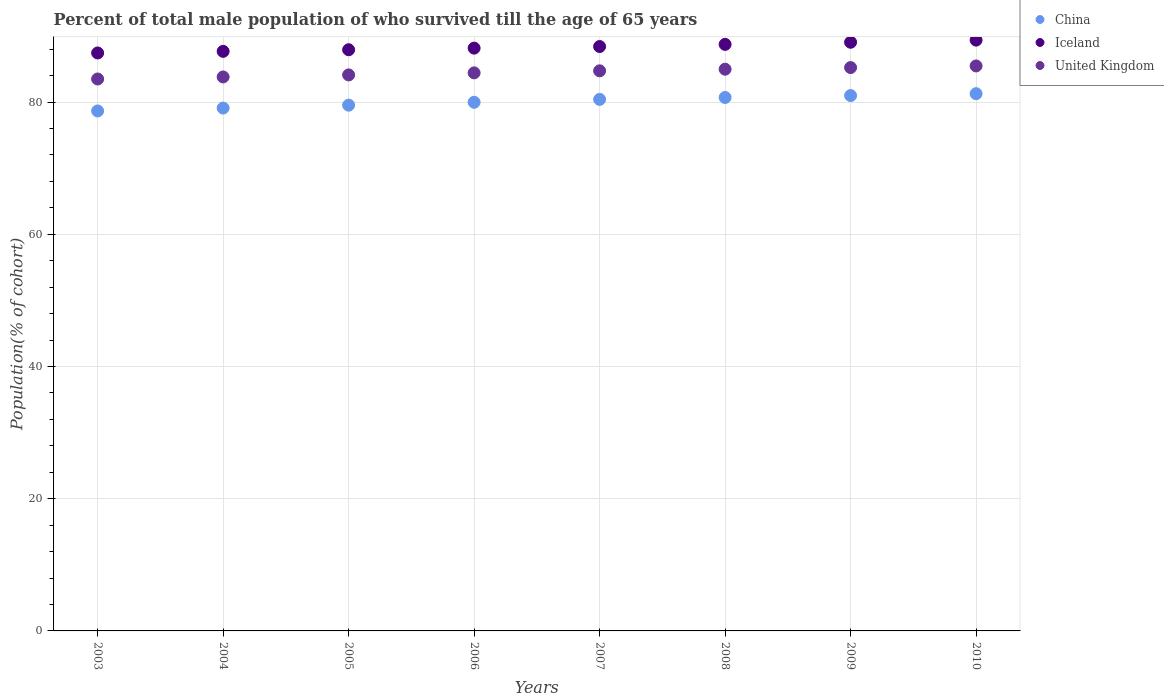What is the percentage of total male population who survived till the age of 65 years in Iceland in 2007?
Provide a short and direct response. 88.41. Across all years, what is the maximum percentage of total male population who survived till the age of 65 years in China?
Give a very brief answer. 81.27. Across all years, what is the minimum percentage of total male population who survived till the age of 65 years in Iceland?
Offer a very short reply. 87.43. In which year was the percentage of total male population who survived till the age of 65 years in China minimum?
Offer a terse response. 2003. What is the total percentage of total male population who survived till the age of 65 years in Iceland in the graph?
Make the answer very short. 706.75. What is the difference between the percentage of total male population who survived till the age of 65 years in United Kingdom in 2005 and that in 2006?
Make the answer very short. -0.31. What is the difference between the percentage of total male population who survived till the age of 65 years in United Kingdom in 2004 and the percentage of total male population who survived till the age of 65 years in Iceland in 2010?
Your response must be concise. -5.57. What is the average percentage of total male population who survived till the age of 65 years in United Kingdom per year?
Offer a very short reply. 84.53. In the year 2008, what is the difference between the percentage of total male population who survived till the age of 65 years in Iceland and percentage of total male population who survived till the age of 65 years in China?
Provide a succinct answer. 8.03. In how many years, is the percentage of total male population who survived till the age of 65 years in United Kingdom greater than 36 %?
Your answer should be compact. 8. What is the ratio of the percentage of total male population who survived till the age of 65 years in United Kingdom in 2007 to that in 2008?
Provide a short and direct response. 1. Is the percentage of total male population who survived till the age of 65 years in China in 2003 less than that in 2005?
Keep it short and to the point. Yes. What is the difference between the highest and the second highest percentage of total male population who survived till the age of 65 years in United Kingdom?
Ensure brevity in your answer.  0.25. What is the difference between the highest and the lowest percentage of total male population who survived till the age of 65 years in United Kingdom?
Your response must be concise. 1.97. Is the sum of the percentage of total male population who survived till the age of 65 years in Iceland in 2006 and 2009 greater than the maximum percentage of total male population who survived till the age of 65 years in United Kingdom across all years?
Your answer should be very brief. Yes. Does the percentage of total male population who survived till the age of 65 years in Iceland monotonically increase over the years?
Your response must be concise. Yes. Is the percentage of total male population who survived till the age of 65 years in China strictly greater than the percentage of total male population who survived till the age of 65 years in United Kingdom over the years?
Your response must be concise. No. Is the percentage of total male population who survived till the age of 65 years in Iceland strictly less than the percentage of total male population who survived till the age of 65 years in United Kingdom over the years?
Your answer should be very brief. No. How many dotlines are there?
Provide a short and direct response. 3. How many years are there in the graph?
Offer a terse response. 8. What is the difference between two consecutive major ticks on the Y-axis?
Keep it short and to the point. 20. Does the graph contain any zero values?
Give a very brief answer. No. How many legend labels are there?
Make the answer very short. 3. What is the title of the graph?
Ensure brevity in your answer.  Percent of total male population of who survived till the age of 65 years. What is the label or title of the Y-axis?
Offer a very short reply. Population(% of cohort). What is the Population(% of cohort) of China in 2003?
Offer a very short reply. 78.66. What is the Population(% of cohort) of Iceland in 2003?
Make the answer very short. 87.43. What is the Population(% of cohort) in United Kingdom in 2003?
Ensure brevity in your answer.  83.49. What is the Population(% of cohort) in China in 2004?
Ensure brevity in your answer.  79.1. What is the Population(% of cohort) of Iceland in 2004?
Your answer should be compact. 87.67. What is the Population(% of cohort) of United Kingdom in 2004?
Keep it short and to the point. 83.8. What is the Population(% of cohort) in China in 2005?
Make the answer very short. 79.53. What is the Population(% of cohort) in Iceland in 2005?
Provide a succinct answer. 87.92. What is the Population(% of cohort) of United Kingdom in 2005?
Your answer should be compact. 84.11. What is the Population(% of cohort) of China in 2006?
Offer a very short reply. 79.97. What is the Population(% of cohort) in Iceland in 2006?
Your answer should be compact. 88.16. What is the Population(% of cohort) in United Kingdom in 2006?
Your answer should be very brief. 84.42. What is the Population(% of cohort) of China in 2007?
Provide a short and direct response. 80.41. What is the Population(% of cohort) of Iceland in 2007?
Ensure brevity in your answer.  88.41. What is the Population(% of cohort) of United Kingdom in 2007?
Give a very brief answer. 84.73. What is the Population(% of cohort) of China in 2008?
Your response must be concise. 80.7. What is the Population(% of cohort) of Iceland in 2008?
Make the answer very short. 88.73. What is the Population(% of cohort) of United Kingdom in 2008?
Provide a short and direct response. 84.98. What is the Population(% of cohort) in China in 2009?
Your response must be concise. 80.99. What is the Population(% of cohort) in Iceland in 2009?
Your answer should be very brief. 89.05. What is the Population(% of cohort) of United Kingdom in 2009?
Your answer should be compact. 85.22. What is the Population(% of cohort) in China in 2010?
Offer a terse response. 81.27. What is the Population(% of cohort) of Iceland in 2010?
Offer a very short reply. 89.37. What is the Population(% of cohort) of United Kingdom in 2010?
Offer a very short reply. 85.47. Across all years, what is the maximum Population(% of cohort) in China?
Give a very brief answer. 81.27. Across all years, what is the maximum Population(% of cohort) of Iceland?
Offer a terse response. 89.37. Across all years, what is the maximum Population(% of cohort) of United Kingdom?
Provide a succinct answer. 85.47. Across all years, what is the minimum Population(% of cohort) of China?
Your response must be concise. 78.66. Across all years, what is the minimum Population(% of cohort) in Iceland?
Provide a short and direct response. 87.43. Across all years, what is the minimum Population(% of cohort) of United Kingdom?
Provide a short and direct response. 83.49. What is the total Population(% of cohort) of China in the graph?
Your answer should be compact. 640.63. What is the total Population(% of cohort) of Iceland in the graph?
Your response must be concise. 706.75. What is the total Population(% of cohort) of United Kingdom in the graph?
Give a very brief answer. 676.22. What is the difference between the Population(% of cohort) in China in 2003 and that in 2004?
Give a very brief answer. -0.44. What is the difference between the Population(% of cohort) of Iceland in 2003 and that in 2004?
Your response must be concise. -0.24. What is the difference between the Population(% of cohort) of United Kingdom in 2003 and that in 2004?
Ensure brevity in your answer.  -0.31. What is the difference between the Population(% of cohort) of China in 2003 and that in 2005?
Provide a succinct answer. -0.88. What is the difference between the Population(% of cohort) of Iceland in 2003 and that in 2005?
Provide a succinct answer. -0.49. What is the difference between the Population(% of cohort) in United Kingdom in 2003 and that in 2005?
Your answer should be compact. -0.62. What is the difference between the Population(% of cohort) in China in 2003 and that in 2006?
Make the answer very short. -1.31. What is the difference between the Population(% of cohort) in Iceland in 2003 and that in 2006?
Your answer should be compact. -0.73. What is the difference between the Population(% of cohort) of United Kingdom in 2003 and that in 2006?
Your answer should be very brief. -0.93. What is the difference between the Population(% of cohort) in China in 2003 and that in 2007?
Your response must be concise. -1.75. What is the difference between the Population(% of cohort) of Iceland in 2003 and that in 2007?
Offer a very short reply. -0.97. What is the difference between the Population(% of cohort) in United Kingdom in 2003 and that in 2007?
Provide a succinct answer. -1.24. What is the difference between the Population(% of cohort) of China in 2003 and that in 2008?
Your response must be concise. -2.04. What is the difference between the Population(% of cohort) of Iceland in 2003 and that in 2008?
Offer a terse response. -1.3. What is the difference between the Population(% of cohort) in United Kingdom in 2003 and that in 2008?
Keep it short and to the point. -1.48. What is the difference between the Population(% of cohort) in China in 2003 and that in 2009?
Give a very brief answer. -2.33. What is the difference between the Population(% of cohort) of Iceland in 2003 and that in 2009?
Make the answer very short. -1.62. What is the difference between the Population(% of cohort) of United Kingdom in 2003 and that in 2009?
Offer a very short reply. -1.73. What is the difference between the Population(% of cohort) in China in 2003 and that in 2010?
Make the answer very short. -2.61. What is the difference between the Population(% of cohort) in Iceland in 2003 and that in 2010?
Your answer should be very brief. -1.94. What is the difference between the Population(% of cohort) of United Kingdom in 2003 and that in 2010?
Your answer should be compact. -1.97. What is the difference between the Population(% of cohort) of China in 2004 and that in 2005?
Offer a terse response. -0.44. What is the difference between the Population(% of cohort) of Iceland in 2004 and that in 2005?
Provide a short and direct response. -0.24. What is the difference between the Population(% of cohort) in United Kingdom in 2004 and that in 2005?
Provide a short and direct response. -0.31. What is the difference between the Population(% of cohort) of China in 2004 and that in 2006?
Your answer should be very brief. -0.88. What is the difference between the Population(% of cohort) in Iceland in 2004 and that in 2006?
Offer a very short reply. -0.49. What is the difference between the Population(% of cohort) of United Kingdom in 2004 and that in 2006?
Offer a terse response. -0.62. What is the difference between the Population(% of cohort) of China in 2004 and that in 2007?
Make the answer very short. -1.31. What is the difference between the Population(% of cohort) in Iceland in 2004 and that in 2007?
Make the answer very short. -0.73. What is the difference between the Population(% of cohort) of United Kingdom in 2004 and that in 2007?
Provide a succinct answer. -0.93. What is the difference between the Population(% of cohort) in China in 2004 and that in 2008?
Your answer should be compact. -1.6. What is the difference between the Population(% of cohort) of Iceland in 2004 and that in 2008?
Offer a very short reply. -1.05. What is the difference between the Population(% of cohort) in United Kingdom in 2004 and that in 2008?
Keep it short and to the point. -1.17. What is the difference between the Population(% of cohort) of China in 2004 and that in 2009?
Ensure brevity in your answer.  -1.89. What is the difference between the Population(% of cohort) in Iceland in 2004 and that in 2009?
Give a very brief answer. -1.38. What is the difference between the Population(% of cohort) of United Kingdom in 2004 and that in 2009?
Ensure brevity in your answer.  -1.42. What is the difference between the Population(% of cohort) in China in 2004 and that in 2010?
Give a very brief answer. -2.18. What is the difference between the Population(% of cohort) in United Kingdom in 2004 and that in 2010?
Your answer should be very brief. -1.67. What is the difference between the Population(% of cohort) of China in 2005 and that in 2006?
Provide a short and direct response. -0.44. What is the difference between the Population(% of cohort) in Iceland in 2005 and that in 2006?
Offer a very short reply. -0.24. What is the difference between the Population(% of cohort) in United Kingdom in 2005 and that in 2006?
Your response must be concise. -0.31. What is the difference between the Population(% of cohort) of China in 2005 and that in 2007?
Provide a short and direct response. -0.88. What is the difference between the Population(% of cohort) of Iceland in 2005 and that in 2007?
Give a very brief answer. -0.49. What is the difference between the Population(% of cohort) in United Kingdom in 2005 and that in 2007?
Make the answer very short. -0.62. What is the difference between the Population(% of cohort) of China in 2005 and that in 2008?
Make the answer very short. -1.16. What is the difference between the Population(% of cohort) of Iceland in 2005 and that in 2008?
Provide a short and direct response. -0.81. What is the difference between the Population(% of cohort) in United Kingdom in 2005 and that in 2008?
Your answer should be compact. -0.86. What is the difference between the Population(% of cohort) in China in 2005 and that in 2009?
Give a very brief answer. -1.45. What is the difference between the Population(% of cohort) in Iceland in 2005 and that in 2009?
Offer a very short reply. -1.13. What is the difference between the Population(% of cohort) of United Kingdom in 2005 and that in 2009?
Offer a terse response. -1.11. What is the difference between the Population(% of cohort) of China in 2005 and that in 2010?
Ensure brevity in your answer.  -1.74. What is the difference between the Population(% of cohort) of Iceland in 2005 and that in 2010?
Your answer should be very brief. -1.46. What is the difference between the Population(% of cohort) of United Kingdom in 2005 and that in 2010?
Ensure brevity in your answer.  -1.36. What is the difference between the Population(% of cohort) in China in 2006 and that in 2007?
Provide a short and direct response. -0.44. What is the difference between the Population(% of cohort) in Iceland in 2006 and that in 2007?
Ensure brevity in your answer.  -0.24. What is the difference between the Population(% of cohort) of United Kingdom in 2006 and that in 2007?
Offer a terse response. -0.31. What is the difference between the Population(% of cohort) of China in 2006 and that in 2008?
Provide a short and direct response. -0.73. What is the difference between the Population(% of cohort) of Iceland in 2006 and that in 2008?
Provide a short and direct response. -0.57. What is the difference between the Population(% of cohort) in United Kingdom in 2006 and that in 2008?
Keep it short and to the point. -0.56. What is the difference between the Population(% of cohort) in China in 2006 and that in 2009?
Provide a short and direct response. -1.01. What is the difference between the Population(% of cohort) in Iceland in 2006 and that in 2009?
Make the answer very short. -0.89. What is the difference between the Population(% of cohort) of United Kingdom in 2006 and that in 2009?
Your response must be concise. -0.8. What is the difference between the Population(% of cohort) of China in 2006 and that in 2010?
Offer a very short reply. -1.3. What is the difference between the Population(% of cohort) of Iceland in 2006 and that in 2010?
Give a very brief answer. -1.21. What is the difference between the Population(% of cohort) of United Kingdom in 2006 and that in 2010?
Provide a succinct answer. -1.05. What is the difference between the Population(% of cohort) of China in 2007 and that in 2008?
Offer a terse response. -0.29. What is the difference between the Population(% of cohort) of Iceland in 2007 and that in 2008?
Offer a terse response. -0.32. What is the difference between the Population(% of cohort) in United Kingdom in 2007 and that in 2008?
Ensure brevity in your answer.  -0.25. What is the difference between the Population(% of cohort) of China in 2007 and that in 2009?
Provide a succinct answer. -0.57. What is the difference between the Population(% of cohort) of Iceland in 2007 and that in 2009?
Your answer should be compact. -0.65. What is the difference between the Population(% of cohort) in United Kingdom in 2007 and that in 2009?
Offer a very short reply. -0.49. What is the difference between the Population(% of cohort) of China in 2007 and that in 2010?
Provide a succinct answer. -0.86. What is the difference between the Population(% of cohort) in Iceland in 2007 and that in 2010?
Offer a very short reply. -0.97. What is the difference between the Population(% of cohort) of United Kingdom in 2007 and that in 2010?
Make the answer very short. -0.74. What is the difference between the Population(% of cohort) in China in 2008 and that in 2009?
Offer a terse response. -0.29. What is the difference between the Population(% of cohort) in Iceland in 2008 and that in 2009?
Ensure brevity in your answer.  -0.32. What is the difference between the Population(% of cohort) of United Kingdom in 2008 and that in 2009?
Offer a terse response. -0.25. What is the difference between the Population(% of cohort) of China in 2008 and that in 2010?
Make the answer very short. -0.57. What is the difference between the Population(% of cohort) in Iceland in 2008 and that in 2010?
Give a very brief answer. -0.65. What is the difference between the Population(% of cohort) in United Kingdom in 2008 and that in 2010?
Provide a short and direct response. -0.49. What is the difference between the Population(% of cohort) in China in 2009 and that in 2010?
Provide a short and direct response. -0.29. What is the difference between the Population(% of cohort) of Iceland in 2009 and that in 2010?
Give a very brief answer. -0.32. What is the difference between the Population(% of cohort) of United Kingdom in 2009 and that in 2010?
Offer a terse response. -0.25. What is the difference between the Population(% of cohort) of China in 2003 and the Population(% of cohort) of Iceland in 2004?
Your answer should be compact. -9.02. What is the difference between the Population(% of cohort) of China in 2003 and the Population(% of cohort) of United Kingdom in 2004?
Provide a short and direct response. -5.14. What is the difference between the Population(% of cohort) of Iceland in 2003 and the Population(% of cohort) of United Kingdom in 2004?
Provide a succinct answer. 3.63. What is the difference between the Population(% of cohort) in China in 2003 and the Population(% of cohort) in Iceland in 2005?
Provide a short and direct response. -9.26. What is the difference between the Population(% of cohort) in China in 2003 and the Population(% of cohort) in United Kingdom in 2005?
Provide a succinct answer. -5.45. What is the difference between the Population(% of cohort) in Iceland in 2003 and the Population(% of cohort) in United Kingdom in 2005?
Give a very brief answer. 3.32. What is the difference between the Population(% of cohort) of China in 2003 and the Population(% of cohort) of Iceland in 2006?
Ensure brevity in your answer.  -9.5. What is the difference between the Population(% of cohort) in China in 2003 and the Population(% of cohort) in United Kingdom in 2006?
Ensure brevity in your answer.  -5.76. What is the difference between the Population(% of cohort) in Iceland in 2003 and the Population(% of cohort) in United Kingdom in 2006?
Give a very brief answer. 3.01. What is the difference between the Population(% of cohort) of China in 2003 and the Population(% of cohort) of Iceland in 2007?
Provide a short and direct response. -9.75. What is the difference between the Population(% of cohort) in China in 2003 and the Population(% of cohort) in United Kingdom in 2007?
Your answer should be compact. -6.07. What is the difference between the Population(% of cohort) in Iceland in 2003 and the Population(% of cohort) in United Kingdom in 2007?
Your response must be concise. 2.7. What is the difference between the Population(% of cohort) of China in 2003 and the Population(% of cohort) of Iceland in 2008?
Ensure brevity in your answer.  -10.07. What is the difference between the Population(% of cohort) of China in 2003 and the Population(% of cohort) of United Kingdom in 2008?
Your response must be concise. -6.32. What is the difference between the Population(% of cohort) of Iceland in 2003 and the Population(% of cohort) of United Kingdom in 2008?
Give a very brief answer. 2.46. What is the difference between the Population(% of cohort) of China in 2003 and the Population(% of cohort) of Iceland in 2009?
Provide a short and direct response. -10.39. What is the difference between the Population(% of cohort) of China in 2003 and the Population(% of cohort) of United Kingdom in 2009?
Your answer should be very brief. -6.56. What is the difference between the Population(% of cohort) in Iceland in 2003 and the Population(% of cohort) in United Kingdom in 2009?
Your answer should be compact. 2.21. What is the difference between the Population(% of cohort) of China in 2003 and the Population(% of cohort) of Iceland in 2010?
Offer a terse response. -10.72. What is the difference between the Population(% of cohort) in China in 2003 and the Population(% of cohort) in United Kingdom in 2010?
Keep it short and to the point. -6.81. What is the difference between the Population(% of cohort) of Iceland in 2003 and the Population(% of cohort) of United Kingdom in 2010?
Provide a succinct answer. 1.96. What is the difference between the Population(% of cohort) of China in 2004 and the Population(% of cohort) of Iceland in 2005?
Your answer should be compact. -8.82. What is the difference between the Population(% of cohort) of China in 2004 and the Population(% of cohort) of United Kingdom in 2005?
Your answer should be very brief. -5.01. What is the difference between the Population(% of cohort) in Iceland in 2004 and the Population(% of cohort) in United Kingdom in 2005?
Your answer should be very brief. 3.56. What is the difference between the Population(% of cohort) in China in 2004 and the Population(% of cohort) in Iceland in 2006?
Make the answer very short. -9.07. What is the difference between the Population(% of cohort) in China in 2004 and the Population(% of cohort) in United Kingdom in 2006?
Your answer should be compact. -5.32. What is the difference between the Population(% of cohort) in Iceland in 2004 and the Population(% of cohort) in United Kingdom in 2006?
Offer a very short reply. 3.25. What is the difference between the Population(% of cohort) in China in 2004 and the Population(% of cohort) in Iceland in 2007?
Give a very brief answer. -9.31. What is the difference between the Population(% of cohort) of China in 2004 and the Population(% of cohort) of United Kingdom in 2007?
Ensure brevity in your answer.  -5.63. What is the difference between the Population(% of cohort) of Iceland in 2004 and the Population(% of cohort) of United Kingdom in 2007?
Your answer should be very brief. 2.95. What is the difference between the Population(% of cohort) in China in 2004 and the Population(% of cohort) in Iceland in 2008?
Your response must be concise. -9.63. What is the difference between the Population(% of cohort) of China in 2004 and the Population(% of cohort) of United Kingdom in 2008?
Make the answer very short. -5.88. What is the difference between the Population(% of cohort) of Iceland in 2004 and the Population(% of cohort) of United Kingdom in 2008?
Make the answer very short. 2.7. What is the difference between the Population(% of cohort) of China in 2004 and the Population(% of cohort) of Iceland in 2009?
Offer a terse response. -9.96. What is the difference between the Population(% of cohort) of China in 2004 and the Population(% of cohort) of United Kingdom in 2009?
Make the answer very short. -6.13. What is the difference between the Population(% of cohort) of Iceland in 2004 and the Population(% of cohort) of United Kingdom in 2009?
Offer a very short reply. 2.45. What is the difference between the Population(% of cohort) of China in 2004 and the Population(% of cohort) of Iceland in 2010?
Keep it short and to the point. -10.28. What is the difference between the Population(% of cohort) of China in 2004 and the Population(% of cohort) of United Kingdom in 2010?
Provide a short and direct response. -6.37. What is the difference between the Population(% of cohort) in Iceland in 2004 and the Population(% of cohort) in United Kingdom in 2010?
Your answer should be very brief. 2.21. What is the difference between the Population(% of cohort) in China in 2005 and the Population(% of cohort) in Iceland in 2006?
Ensure brevity in your answer.  -8.63. What is the difference between the Population(% of cohort) of China in 2005 and the Population(% of cohort) of United Kingdom in 2006?
Your response must be concise. -4.89. What is the difference between the Population(% of cohort) of Iceland in 2005 and the Population(% of cohort) of United Kingdom in 2006?
Provide a short and direct response. 3.5. What is the difference between the Population(% of cohort) in China in 2005 and the Population(% of cohort) in Iceland in 2007?
Offer a very short reply. -8.87. What is the difference between the Population(% of cohort) of China in 2005 and the Population(% of cohort) of United Kingdom in 2007?
Your response must be concise. -5.19. What is the difference between the Population(% of cohort) of Iceland in 2005 and the Population(% of cohort) of United Kingdom in 2007?
Your response must be concise. 3.19. What is the difference between the Population(% of cohort) in China in 2005 and the Population(% of cohort) in Iceland in 2008?
Your response must be concise. -9.19. What is the difference between the Population(% of cohort) in China in 2005 and the Population(% of cohort) in United Kingdom in 2008?
Offer a terse response. -5.44. What is the difference between the Population(% of cohort) of Iceland in 2005 and the Population(% of cohort) of United Kingdom in 2008?
Keep it short and to the point. 2.94. What is the difference between the Population(% of cohort) of China in 2005 and the Population(% of cohort) of Iceland in 2009?
Ensure brevity in your answer.  -9.52. What is the difference between the Population(% of cohort) in China in 2005 and the Population(% of cohort) in United Kingdom in 2009?
Ensure brevity in your answer.  -5.69. What is the difference between the Population(% of cohort) of Iceland in 2005 and the Population(% of cohort) of United Kingdom in 2009?
Offer a very short reply. 2.7. What is the difference between the Population(% of cohort) of China in 2005 and the Population(% of cohort) of Iceland in 2010?
Offer a very short reply. -9.84. What is the difference between the Population(% of cohort) in China in 2005 and the Population(% of cohort) in United Kingdom in 2010?
Offer a very short reply. -5.93. What is the difference between the Population(% of cohort) in Iceland in 2005 and the Population(% of cohort) in United Kingdom in 2010?
Your answer should be very brief. 2.45. What is the difference between the Population(% of cohort) in China in 2006 and the Population(% of cohort) in Iceland in 2007?
Make the answer very short. -8.43. What is the difference between the Population(% of cohort) of China in 2006 and the Population(% of cohort) of United Kingdom in 2007?
Provide a succinct answer. -4.76. What is the difference between the Population(% of cohort) in Iceland in 2006 and the Population(% of cohort) in United Kingdom in 2007?
Keep it short and to the point. 3.43. What is the difference between the Population(% of cohort) of China in 2006 and the Population(% of cohort) of Iceland in 2008?
Provide a succinct answer. -8.76. What is the difference between the Population(% of cohort) of China in 2006 and the Population(% of cohort) of United Kingdom in 2008?
Offer a terse response. -5. What is the difference between the Population(% of cohort) in Iceland in 2006 and the Population(% of cohort) in United Kingdom in 2008?
Your response must be concise. 3.19. What is the difference between the Population(% of cohort) in China in 2006 and the Population(% of cohort) in Iceland in 2009?
Give a very brief answer. -9.08. What is the difference between the Population(% of cohort) of China in 2006 and the Population(% of cohort) of United Kingdom in 2009?
Make the answer very short. -5.25. What is the difference between the Population(% of cohort) in Iceland in 2006 and the Population(% of cohort) in United Kingdom in 2009?
Ensure brevity in your answer.  2.94. What is the difference between the Population(% of cohort) in China in 2006 and the Population(% of cohort) in Iceland in 2010?
Ensure brevity in your answer.  -9.4. What is the difference between the Population(% of cohort) in China in 2006 and the Population(% of cohort) in United Kingdom in 2010?
Your answer should be compact. -5.5. What is the difference between the Population(% of cohort) of Iceland in 2006 and the Population(% of cohort) of United Kingdom in 2010?
Give a very brief answer. 2.69. What is the difference between the Population(% of cohort) of China in 2007 and the Population(% of cohort) of Iceland in 2008?
Offer a terse response. -8.32. What is the difference between the Population(% of cohort) of China in 2007 and the Population(% of cohort) of United Kingdom in 2008?
Your answer should be very brief. -4.57. What is the difference between the Population(% of cohort) in Iceland in 2007 and the Population(% of cohort) in United Kingdom in 2008?
Make the answer very short. 3.43. What is the difference between the Population(% of cohort) of China in 2007 and the Population(% of cohort) of Iceland in 2009?
Ensure brevity in your answer.  -8.64. What is the difference between the Population(% of cohort) of China in 2007 and the Population(% of cohort) of United Kingdom in 2009?
Your answer should be compact. -4.81. What is the difference between the Population(% of cohort) in Iceland in 2007 and the Population(% of cohort) in United Kingdom in 2009?
Your answer should be very brief. 3.18. What is the difference between the Population(% of cohort) of China in 2007 and the Population(% of cohort) of Iceland in 2010?
Make the answer very short. -8.96. What is the difference between the Population(% of cohort) in China in 2007 and the Population(% of cohort) in United Kingdom in 2010?
Your answer should be very brief. -5.06. What is the difference between the Population(% of cohort) in Iceland in 2007 and the Population(% of cohort) in United Kingdom in 2010?
Your answer should be compact. 2.94. What is the difference between the Population(% of cohort) in China in 2008 and the Population(% of cohort) in Iceland in 2009?
Offer a terse response. -8.35. What is the difference between the Population(% of cohort) of China in 2008 and the Population(% of cohort) of United Kingdom in 2009?
Keep it short and to the point. -4.52. What is the difference between the Population(% of cohort) in Iceland in 2008 and the Population(% of cohort) in United Kingdom in 2009?
Offer a terse response. 3.51. What is the difference between the Population(% of cohort) of China in 2008 and the Population(% of cohort) of Iceland in 2010?
Your answer should be very brief. -8.68. What is the difference between the Population(% of cohort) in China in 2008 and the Population(% of cohort) in United Kingdom in 2010?
Your answer should be very brief. -4.77. What is the difference between the Population(% of cohort) of Iceland in 2008 and the Population(% of cohort) of United Kingdom in 2010?
Give a very brief answer. 3.26. What is the difference between the Population(% of cohort) in China in 2009 and the Population(% of cohort) in Iceland in 2010?
Offer a very short reply. -8.39. What is the difference between the Population(% of cohort) of China in 2009 and the Population(% of cohort) of United Kingdom in 2010?
Give a very brief answer. -4.48. What is the difference between the Population(% of cohort) of Iceland in 2009 and the Population(% of cohort) of United Kingdom in 2010?
Offer a very short reply. 3.58. What is the average Population(% of cohort) in China per year?
Your answer should be very brief. 80.08. What is the average Population(% of cohort) of Iceland per year?
Give a very brief answer. 88.34. What is the average Population(% of cohort) in United Kingdom per year?
Your response must be concise. 84.53. In the year 2003, what is the difference between the Population(% of cohort) in China and Population(% of cohort) in Iceland?
Ensure brevity in your answer.  -8.77. In the year 2003, what is the difference between the Population(% of cohort) of China and Population(% of cohort) of United Kingdom?
Give a very brief answer. -4.83. In the year 2003, what is the difference between the Population(% of cohort) of Iceland and Population(% of cohort) of United Kingdom?
Your answer should be compact. 3.94. In the year 2004, what is the difference between the Population(% of cohort) in China and Population(% of cohort) in Iceland?
Provide a succinct answer. -8.58. In the year 2004, what is the difference between the Population(% of cohort) in China and Population(% of cohort) in United Kingdom?
Make the answer very short. -4.71. In the year 2004, what is the difference between the Population(% of cohort) in Iceland and Population(% of cohort) in United Kingdom?
Offer a very short reply. 3.87. In the year 2005, what is the difference between the Population(% of cohort) of China and Population(% of cohort) of Iceland?
Provide a succinct answer. -8.38. In the year 2005, what is the difference between the Population(% of cohort) of China and Population(% of cohort) of United Kingdom?
Ensure brevity in your answer.  -4.58. In the year 2005, what is the difference between the Population(% of cohort) of Iceland and Population(% of cohort) of United Kingdom?
Your response must be concise. 3.81. In the year 2006, what is the difference between the Population(% of cohort) in China and Population(% of cohort) in Iceland?
Offer a very short reply. -8.19. In the year 2006, what is the difference between the Population(% of cohort) of China and Population(% of cohort) of United Kingdom?
Offer a terse response. -4.45. In the year 2006, what is the difference between the Population(% of cohort) of Iceland and Population(% of cohort) of United Kingdom?
Make the answer very short. 3.74. In the year 2007, what is the difference between the Population(% of cohort) of China and Population(% of cohort) of Iceland?
Make the answer very short. -8. In the year 2007, what is the difference between the Population(% of cohort) of China and Population(% of cohort) of United Kingdom?
Ensure brevity in your answer.  -4.32. In the year 2007, what is the difference between the Population(% of cohort) in Iceland and Population(% of cohort) in United Kingdom?
Keep it short and to the point. 3.68. In the year 2008, what is the difference between the Population(% of cohort) of China and Population(% of cohort) of Iceland?
Your response must be concise. -8.03. In the year 2008, what is the difference between the Population(% of cohort) of China and Population(% of cohort) of United Kingdom?
Your answer should be compact. -4.28. In the year 2008, what is the difference between the Population(% of cohort) in Iceland and Population(% of cohort) in United Kingdom?
Offer a very short reply. 3.75. In the year 2009, what is the difference between the Population(% of cohort) in China and Population(% of cohort) in Iceland?
Make the answer very short. -8.07. In the year 2009, what is the difference between the Population(% of cohort) in China and Population(% of cohort) in United Kingdom?
Your answer should be very brief. -4.24. In the year 2009, what is the difference between the Population(% of cohort) of Iceland and Population(% of cohort) of United Kingdom?
Give a very brief answer. 3.83. In the year 2010, what is the difference between the Population(% of cohort) of China and Population(% of cohort) of Iceland?
Give a very brief answer. -8.1. In the year 2010, what is the difference between the Population(% of cohort) in China and Population(% of cohort) in United Kingdom?
Make the answer very short. -4.2. In the year 2010, what is the difference between the Population(% of cohort) of Iceland and Population(% of cohort) of United Kingdom?
Your answer should be compact. 3.91. What is the ratio of the Population(% of cohort) of Iceland in 2003 to that in 2004?
Make the answer very short. 1. What is the ratio of the Population(% of cohort) in China in 2003 to that in 2005?
Give a very brief answer. 0.99. What is the ratio of the Population(% of cohort) in Iceland in 2003 to that in 2005?
Keep it short and to the point. 0.99. What is the ratio of the Population(% of cohort) of China in 2003 to that in 2006?
Offer a very short reply. 0.98. What is the ratio of the Population(% of cohort) in Iceland in 2003 to that in 2006?
Give a very brief answer. 0.99. What is the ratio of the Population(% of cohort) in United Kingdom in 2003 to that in 2006?
Offer a very short reply. 0.99. What is the ratio of the Population(% of cohort) in China in 2003 to that in 2007?
Make the answer very short. 0.98. What is the ratio of the Population(% of cohort) in Iceland in 2003 to that in 2007?
Your answer should be very brief. 0.99. What is the ratio of the Population(% of cohort) of United Kingdom in 2003 to that in 2007?
Ensure brevity in your answer.  0.99. What is the ratio of the Population(% of cohort) of China in 2003 to that in 2008?
Offer a very short reply. 0.97. What is the ratio of the Population(% of cohort) in Iceland in 2003 to that in 2008?
Offer a very short reply. 0.99. What is the ratio of the Population(% of cohort) in United Kingdom in 2003 to that in 2008?
Give a very brief answer. 0.98. What is the ratio of the Population(% of cohort) of China in 2003 to that in 2009?
Your answer should be very brief. 0.97. What is the ratio of the Population(% of cohort) in Iceland in 2003 to that in 2009?
Keep it short and to the point. 0.98. What is the ratio of the Population(% of cohort) of United Kingdom in 2003 to that in 2009?
Offer a very short reply. 0.98. What is the ratio of the Population(% of cohort) in China in 2003 to that in 2010?
Provide a short and direct response. 0.97. What is the ratio of the Population(% of cohort) in Iceland in 2003 to that in 2010?
Offer a terse response. 0.98. What is the ratio of the Population(% of cohort) of United Kingdom in 2003 to that in 2010?
Give a very brief answer. 0.98. What is the ratio of the Population(% of cohort) in China in 2004 to that in 2005?
Provide a succinct answer. 0.99. What is the ratio of the Population(% of cohort) in Iceland in 2004 to that in 2005?
Your answer should be very brief. 1. What is the ratio of the Population(% of cohort) in United Kingdom in 2004 to that in 2005?
Provide a short and direct response. 1. What is the ratio of the Population(% of cohort) in China in 2004 to that in 2006?
Provide a short and direct response. 0.99. What is the ratio of the Population(% of cohort) of United Kingdom in 2004 to that in 2006?
Ensure brevity in your answer.  0.99. What is the ratio of the Population(% of cohort) of China in 2004 to that in 2007?
Give a very brief answer. 0.98. What is the ratio of the Population(% of cohort) in Iceland in 2004 to that in 2007?
Your answer should be compact. 0.99. What is the ratio of the Population(% of cohort) of United Kingdom in 2004 to that in 2007?
Provide a short and direct response. 0.99. What is the ratio of the Population(% of cohort) of China in 2004 to that in 2008?
Provide a succinct answer. 0.98. What is the ratio of the Population(% of cohort) in United Kingdom in 2004 to that in 2008?
Offer a very short reply. 0.99. What is the ratio of the Population(% of cohort) of China in 2004 to that in 2009?
Offer a very short reply. 0.98. What is the ratio of the Population(% of cohort) of Iceland in 2004 to that in 2009?
Offer a very short reply. 0.98. What is the ratio of the Population(% of cohort) of United Kingdom in 2004 to that in 2009?
Your response must be concise. 0.98. What is the ratio of the Population(% of cohort) in China in 2004 to that in 2010?
Provide a succinct answer. 0.97. What is the ratio of the Population(% of cohort) in United Kingdom in 2004 to that in 2010?
Provide a short and direct response. 0.98. What is the ratio of the Population(% of cohort) of China in 2005 to that in 2006?
Make the answer very short. 0.99. What is the ratio of the Population(% of cohort) in Iceland in 2005 to that in 2007?
Offer a terse response. 0.99. What is the ratio of the Population(% of cohort) in China in 2005 to that in 2008?
Provide a short and direct response. 0.99. What is the ratio of the Population(% of cohort) in Iceland in 2005 to that in 2008?
Give a very brief answer. 0.99. What is the ratio of the Population(% of cohort) in China in 2005 to that in 2009?
Offer a very short reply. 0.98. What is the ratio of the Population(% of cohort) in Iceland in 2005 to that in 2009?
Provide a short and direct response. 0.99. What is the ratio of the Population(% of cohort) of United Kingdom in 2005 to that in 2009?
Your answer should be very brief. 0.99. What is the ratio of the Population(% of cohort) of China in 2005 to that in 2010?
Provide a short and direct response. 0.98. What is the ratio of the Population(% of cohort) in Iceland in 2005 to that in 2010?
Your answer should be very brief. 0.98. What is the ratio of the Population(% of cohort) in United Kingdom in 2005 to that in 2010?
Your answer should be compact. 0.98. What is the ratio of the Population(% of cohort) of China in 2006 to that in 2007?
Provide a succinct answer. 0.99. What is the ratio of the Population(% of cohort) in China in 2006 to that in 2008?
Your answer should be compact. 0.99. What is the ratio of the Population(% of cohort) of United Kingdom in 2006 to that in 2008?
Provide a short and direct response. 0.99. What is the ratio of the Population(% of cohort) of China in 2006 to that in 2009?
Ensure brevity in your answer.  0.99. What is the ratio of the Population(% of cohort) in United Kingdom in 2006 to that in 2009?
Keep it short and to the point. 0.99. What is the ratio of the Population(% of cohort) of China in 2006 to that in 2010?
Your answer should be compact. 0.98. What is the ratio of the Population(% of cohort) of Iceland in 2006 to that in 2010?
Make the answer very short. 0.99. What is the ratio of the Population(% of cohort) of United Kingdom in 2006 to that in 2010?
Provide a short and direct response. 0.99. What is the ratio of the Population(% of cohort) of China in 2007 to that in 2008?
Ensure brevity in your answer.  1. What is the ratio of the Population(% of cohort) of Iceland in 2007 to that in 2008?
Give a very brief answer. 1. What is the ratio of the Population(% of cohort) in China in 2007 to that in 2009?
Provide a short and direct response. 0.99. What is the ratio of the Population(% of cohort) of Iceland in 2007 to that in 2009?
Give a very brief answer. 0.99. What is the ratio of the Population(% of cohort) of China in 2007 to that in 2010?
Your answer should be very brief. 0.99. What is the ratio of the Population(% of cohort) in United Kingdom in 2007 to that in 2010?
Give a very brief answer. 0.99. What is the ratio of the Population(% of cohort) of China in 2008 to that in 2009?
Your answer should be compact. 1. What is the ratio of the Population(% of cohort) in United Kingdom in 2008 to that in 2009?
Offer a very short reply. 1. What is the ratio of the Population(% of cohort) in United Kingdom in 2008 to that in 2010?
Your response must be concise. 0.99. What is the ratio of the Population(% of cohort) of China in 2009 to that in 2010?
Give a very brief answer. 1. What is the ratio of the Population(% of cohort) in Iceland in 2009 to that in 2010?
Your response must be concise. 1. What is the ratio of the Population(% of cohort) of United Kingdom in 2009 to that in 2010?
Keep it short and to the point. 1. What is the difference between the highest and the second highest Population(% of cohort) of China?
Your response must be concise. 0.29. What is the difference between the highest and the second highest Population(% of cohort) in Iceland?
Your answer should be compact. 0.32. What is the difference between the highest and the second highest Population(% of cohort) of United Kingdom?
Make the answer very short. 0.25. What is the difference between the highest and the lowest Population(% of cohort) in China?
Give a very brief answer. 2.61. What is the difference between the highest and the lowest Population(% of cohort) in Iceland?
Offer a terse response. 1.94. What is the difference between the highest and the lowest Population(% of cohort) in United Kingdom?
Your response must be concise. 1.97. 